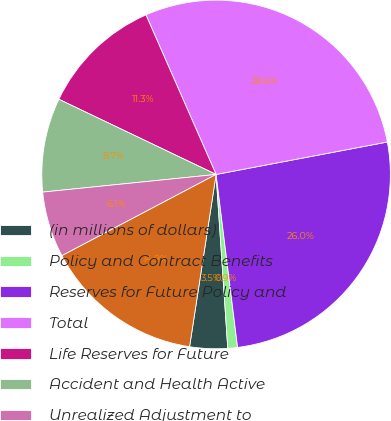<chart> <loc_0><loc_0><loc_500><loc_500><pie_chart><fcel>(in millions of dollars)<fcel>Policy and Contract Benefits<fcel>Reserves for Future Policy and<fcel>Total<fcel>Life Reserves for Future<fcel>Accident and Health Active<fcel>Unrealized Adjustment to<fcel>Liability for Unpaid Claims<nl><fcel>3.5%<fcel>0.9%<fcel>26.01%<fcel>28.61%<fcel>11.31%<fcel>8.71%<fcel>6.1%<fcel>14.85%<nl></chart> 